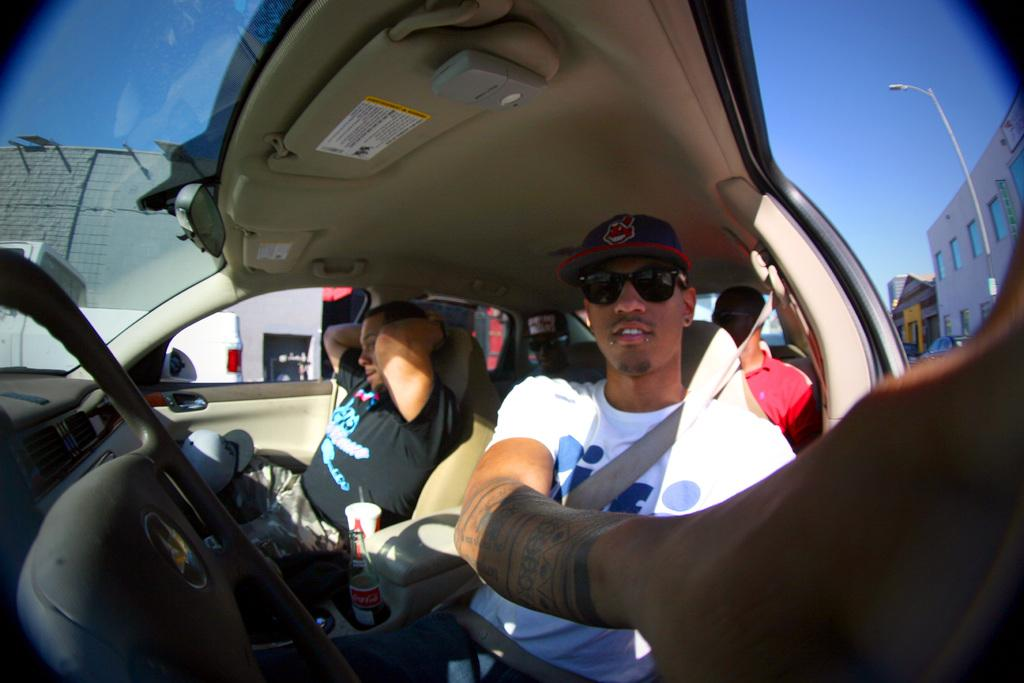What can be seen in the sky in the image? The sky is visible in the image. What type of object is present near the street in the image? There is a street lamp in the image. What type of structures are visible in the background of the image? There are buildings in the image. What are the two people in the car doing? Two people are sitting in a car. What is separating the two people in the car? There is a glass between the two people in the car. Can you see any icicles hanging from the street lamp in the image? There are no icicles visible in the image; the street lamp is not covered in ice. 